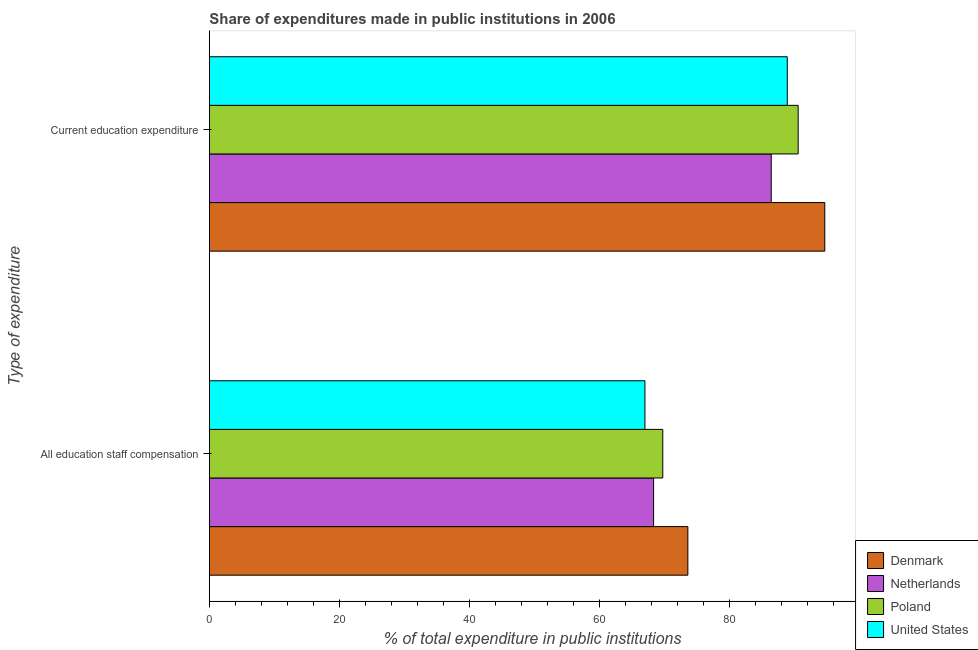How many groups of bars are there?
Ensure brevity in your answer.  2. Are the number of bars per tick equal to the number of legend labels?
Give a very brief answer. Yes. What is the label of the 1st group of bars from the top?
Your answer should be compact. Current education expenditure. What is the expenditure in education in United States?
Provide a short and direct response. 88.83. Across all countries, what is the maximum expenditure in education?
Offer a very short reply. 94.6. Across all countries, what is the minimum expenditure in education?
Offer a terse response. 86.37. What is the total expenditure in staff compensation in the graph?
Make the answer very short. 278.48. What is the difference between the expenditure in staff compensation in Denmark and that in Poland?
Make the answer very short. 3.86. What is the difference between the expenditure in education in Netherlands and the expenditure in staff compensation in Denmark?
Ensure brevity in your answer.  12.82. What is the average expenditure in staff compensation per country?
Your response must be concise. 69.62. What is the difference between the expenditure in staff compensation and expenditure in education in Poland?
Provide a short and direct response. -20.81. What is the ratio of the expenditure in staff compensation in Poland to that in Netherlands?
Make the answer very short. 1.02. In how many countries, is the expenditure in staff compensation greater than the average expenditure in staff compensation taken over all countries?
Offer a terse response. 2. What does the 2nd bar from the top in All education staff compensation represents?
Offer a very short reply. Poland. How many bars are there?
Ensure brevity in your answer.  8. Are all the bars in the graph horizontal?
Give a very brief answer. Yes. What is the difference between two consecutive major ticks on the X-axis?
Offer a very short reply. 20. Does the graph contain any zero values?
Keep it short and to the point. No. Where does the legend appear in the graph?
Make the answer very short. Bottom right. How many legend labels are there?
Your response must be concise. 4. What is the title of the graph?
Your response must be concise. Share of expenditures made in public institutions in 2006. Does "Trinidad and Tobago" appear as one of the legend labels in the graph?
Give a very brief answer. No. What is the label or title of the X-axis?
Ensure brevity in your answer.  % of total expenditure in public institutions. What is the label or title of the Y-axis?
Give a very brief answer. Type of expenditure. What is the % of total expenditure in public institutions in Denmark in All education staff compensation?
Make the answer very short. 73.55. What is the % of total expenditure in public institutions of Netherlands in All education staff compensation?
Provide a short and direct response. 68.28. What is the % of total expenditure in public institutions in Poland in All education staff compensation?
Offer a terse response. 69.7. What is the % of total expenditure in public institutions of United States in All education staff compensation?
Offer a very short reply. 66.95. What is the % of total expenditure in public institutions in Denmark in Current education expenditure?
Make the answer very short. 94.6. What is the % of total expenditure in public institutions in Netherlands in Current education expenditure?
Your answer should be compact. 86.37. What is the % of total expenditure in public institutions in Poland in Current education expenditure?
Your response must be concise. 90.51. What is the % of total expenditure in public institutions in United States in Current education expenditure?
Your answer should be very brief. 88.83. Across all Type of expenditure, what is the maximum % of total expenditure in public institutions in Denmark?
Your response must be concise. 94.6. Across all Type of expenditure, what is the maximum % of total expenditure in public institutions in Netherlands?
Give a very brief answer. 86.37. Across all Type of expenditure, what is the maximum % of total expenditure in public institutions of Poland?
Offer a very short reply. 90.51. Across all Type of expenditure, what is the maximum % of total expenditure in public institutions in United States?
Make the answer very short. 88.83. Across all Type of expenditure, what is the minimum % of total expenditure in public institutions of Denmark?
Keep it short and to the point. 73.55. Across all Type of expenditure, what is the minimum % of total expenditure in public institutions in Netherlands?
Ensure brevity in your answer.  68.28. Across all Type of expenditure, what is the minimum % of total expenditure in public institutions of Poland?
Offer a very short reply. 69.7. Across all Type of expenditure, what is the minimum % of total expenditure in public institutions in United States?
Give a very brief answer. 66.95. What is the total % of total expenditure in public institutions of Denmark in the graph?
Give a very brief answer. 168.15. What is the total % of total expenditure in public institutions of Netherlands in the graph?
Give a very brief answer. 154.65. What is the total % of total expenditure in public institutions in Poland in the graph?
Your answer should be compact. 160.2. What is the total % of total expenditure in public institutions of United States in the graph?
Provide a short and direct response. 155.79. What is the difference between the % of total expenditure in public institutions in Denmark in All education staff compensation and that in Current education expenditure?
Provide a succinct answer. -21.05. What is the difference between the % of total expenditure in public institutions of Netherlands in All education staff compensation and that in Current education expenditure?
Keep it short and to the point. -18.09. What is the difference between the % of total expenditure in public institutions of Poland in All education staff compensation and that in Current education expenditure?
Your answer should be very brief. -20.81. What is the difference between the % of total expenditure in public institutions in United States in All education staff compensation and that in Current education expenditure?
Your response must be concise. -21.88. What is the difference between the % of total expenditure in public institutions of Denmark in All education staff compensation and the % of total expenditure in public institutions of Netherlands in Current education expenditure?
Your answer should be very brief. -12.82. What is the difference between the % of total expenditure in public institutions in Denmark in All education staff compensation and the % of total expenditure in public institutions in Poland in Current education expenditure?
Provide a short and direct response. -16.96. What is the difference between the % of total expenditure in public institutions in Denmark in All education staff compensation and the % of total expenditure in public institutions in United States in Current education expenditure?
Your response must be concise. -15.28. What is the difference between the % of total expenditure in public institutions of Netherlands in All education staff compensation and the % of total expenditure in public institutions of Poland in Current education expenditure?
Give a very brief answer. -22.23. What is the difference between the % of total expenditure in public institutions of Netherlands in All education staff compensation and the % of total expenditure in public institutions of United States in Current education expenditure?
Offer a very short reply. -20.55. What is the difference between the % of total expenditure in public institutions of Poland in All education staff compensation and the % of total expenditure in public institutions of United States in Current education expenditure?
Make the answer very short. -19.14. What is the average % of total expenditure in public institutions in Denmark per Type of expenditure?
Make the answer very short. 84.08. What is the average % of total expenditure in public institutions of Netherlands per Type of expenditure?
Make the answer very short. 77.33. What is the average % of total expenditure in public institutions of Poland per Type of expenditure?
Give a very brief answer. 80.1. What is the average % of total expenditure in public institutions of United States per Type of expenditure?
Your answer should be compact. 77.89. What is the difference between the % of total expenditure in public institutions of Denmark and % of total expenditure in public institutions of Netherlands in All education staff compensation?
Your answer should be compact. 5.27. What is the difference between the % of total expenditure in public institutions in Denmark and % of total expenditure in public institutions in Poland in All education staff compensation?
Provide a succinct answer. 3.86. What is the difference between the % of total expenditure in public institutions in Denmark and % of total expenditure in public institutions in United States in All education staff compensation?
Keep it short and to the point. 6.6. What is the difference between the % of total expenditure in public institutions in Netherlands and % of total expenditure in public institutions in Poland in All education staff compensation?
Provide a short and direct response. -1.41. What is the difference between the % of total expenditure in public institutions in Netherlands and % of total expenditure in public institutions in United States in All education staff compensation?
Provide a short and direct response. 1.33. What is the difference between the % of total expenditure in public institutions in Poland and % of total expenditure in public institutions in United States in All education staff compensation?
Your response must be concise. 2.74. What is the difference between the % of total expenditure in public institutions of Denmark and % of total expenditure in public institutions of Netherlands in Current education expenditure?
Provide a short and direct response. 8.23. What is the difference between the % of total expenditure in public institutions of Denmark and % of total expenditure in public institutions of Poland in Current education expenditure?
Keep it short and to the point. 4.09. What is the difference between the % of total expenditure in public institutions in Denmark and % of total expenditure in public institutions in United States in Current education expenditure?
Make the answer very short. 5.77. What is the difference between the % of total expenditure in public institutions of Netherlands and % of total expenditure in public institutions of Poland in Current education expenditure?
Provide a succinct answer. -4.14. What is the difference between the % of total expenditure in public institutions in Netherlands and % of total expenditure in public institutions in United States in Current education expenditure?
Ensure brevity in your answer.  -2.47. What is the difference between the % of total expenditure in public institutions of Poland and % of total expenditure in public institutions of United States in Current education expenditure?
Your response must be concise. 1.68. What is the ratio of the % of total expenditure in public institutions in Denmark in All education staff compensation to that in Current education expenditure?
Make the answer very short. 0.78. What is the ratio of the % of total expenditure in public institutions in Netherlands in All education staff compensation to that in Current education expenditure?
Provide a short and direct response. 0.79. What is the ratio of the % of total expenditure in public institutions in Poland in All education staff compensation to that in Current education expenditure?
Your response must be concise. 0.77. What is the ratio of the % of total expenditure in public institutions in United States in All education staff compensation to that in Current education expenditure?
Offer a terse response. 0.75. What is the difference between the highest and the second highest % of total expenditure in public institutions in Denmark?
Keep it short and to the point. 21.05. What is the difference between the highest and the second highest % of total expenditure in public institutions in Netherlands?
Make the answer very short. 18.09. What is the difference between the highest and the second highest % of total expenditure in public institutions in Poland?
Provide a succinct answer. 20.81. What is the difference between the highest and the second highest % of total expenditure in public institutions in United States?
Your response must be concise. 21.88. What is the difference between the highest and the lowest % of total expenditure in public institutions of Denmark?
Keep it short and to the point. 21.05. What is the difference between the highest and the lowest % of total expenditure in public institutions of Netherlands?
Ensure brevity in your answer.  18.09. What is the difference between the highest and the lowest % of total expenditure in public institutions of Poland?
Provide a short and direct response. 20.81. What is the difference between the highest and the lowest % of total expenditure in public institutions in United States?
Provide a short and direct response. 21.88. 